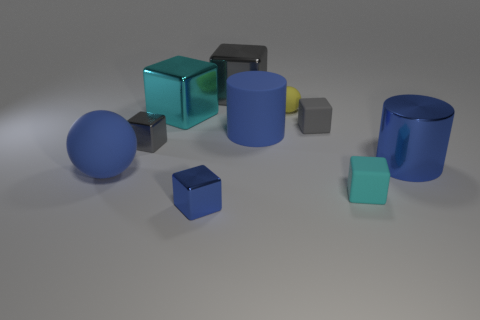The tiny ball has what color?
Provide a succinct answer. Yellow. There is a large thing that is to the right of the tiny cyan matte thing; does it have the same color as the matte cube in front of the large blue matte ball?
Make the answer very short. No. What size is the cyan matte cube?
Provide a succinct answer. Small. There is a gray cube behind the big cyan cube; what is its size?
Ensure brevity in your answer.  Large. The thing that is on the left side of the small blue metallic cube and behind the large blue matte cylinder has what shape?
Offer a very short reply. Cube. What number of other objects are there of the same shape as the tiny blue metal object?
Make the answer very short. 5. There is a ball that is the same size as the gray rubber block; what is its color?
Provide a short and direct response. Yellow. What number of things are either tiny blue metallic spheres or tiny gray objects?
Ensure brevity in your answer.  2. There is a blue sphere; are there any big matte things to the left of it?
Your answer should be compact. No. Is there a big blue cylinder that has the same material as the yellow object?
Your answer should be very brief. Yes. 